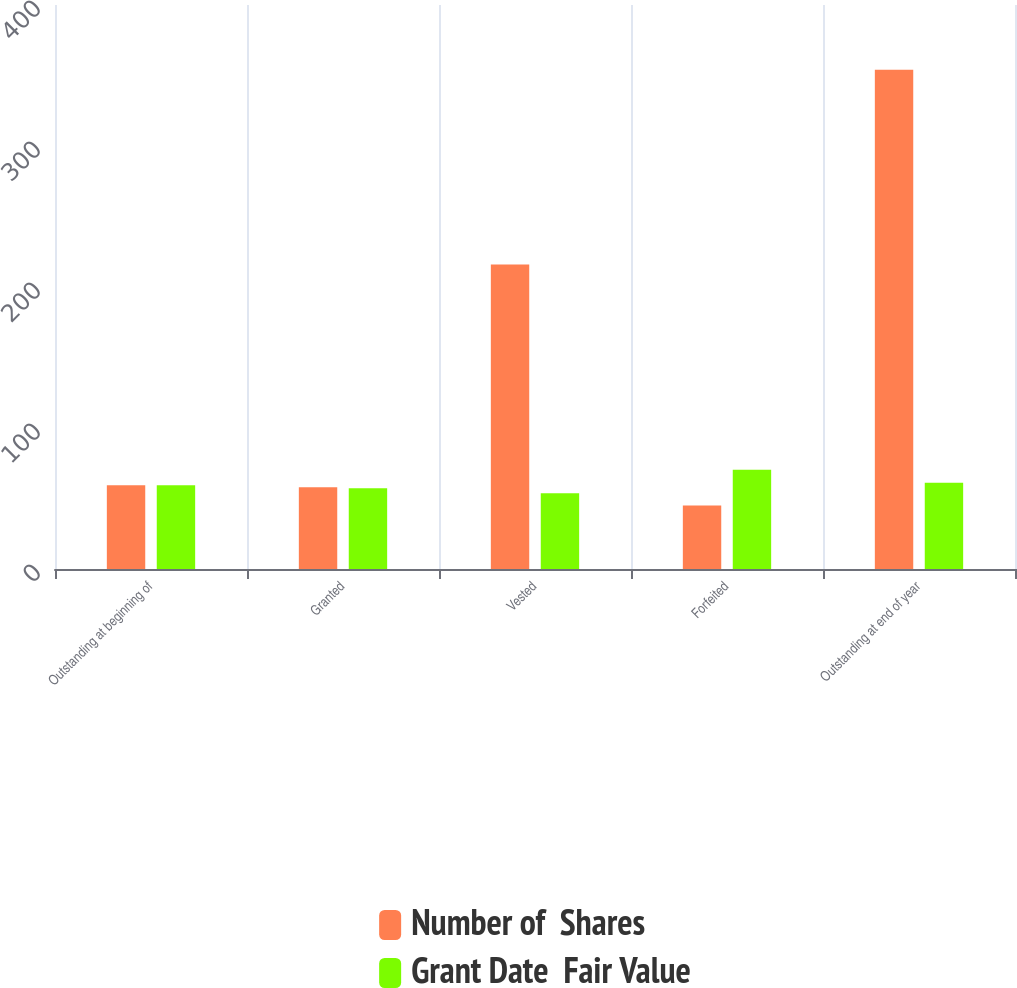Convert chart. <chart><loc_0><loc_0><loc_500><loc_500><stacked_bar_chart><ecel><fcel>Outstanding at beginning of<fcel>Granted<fcel>Vested<fcel>Forfeited<fcel>Outstanding at end of year<nl><fcel>Number of  Shares<fcel>59.42<fcel>58<fcel>216<fcel>45<fcel>354<nl><fcel>Grant Date  Fair Value<fcel>59.42<fcel>57.22<fcel>53.74<fcel>70.37<fcel>61.12<nl></chart> 